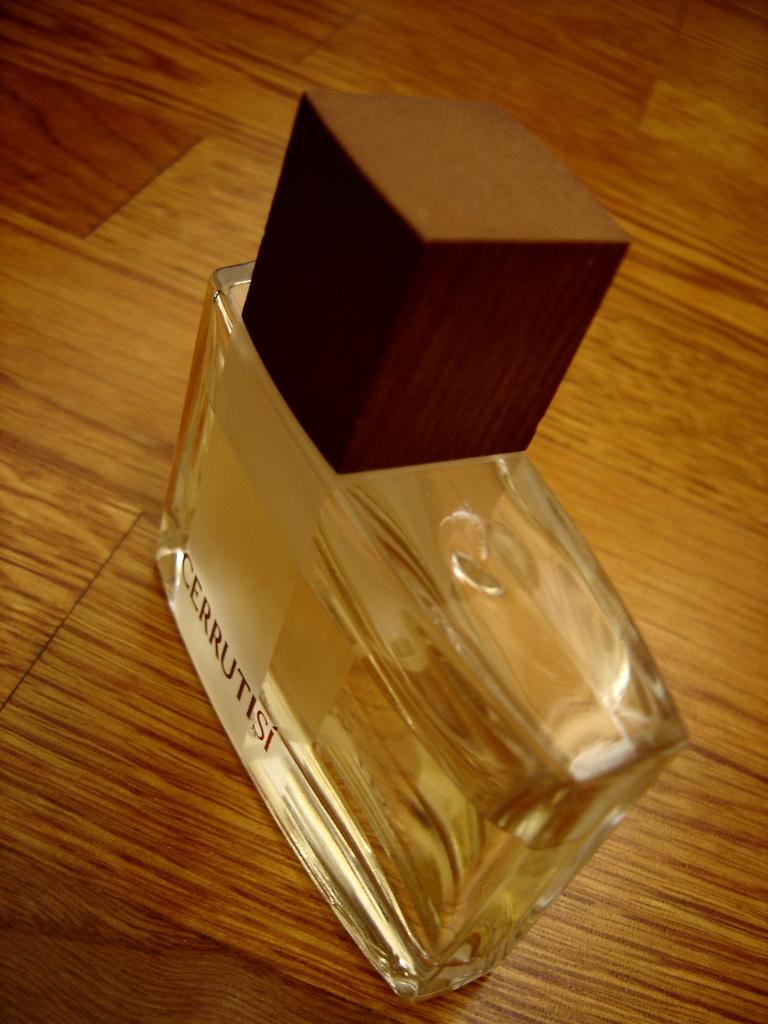Provide a one-sentence caption for the provided image. A bottle of Cerrutisi cologne on a laminate table top. 